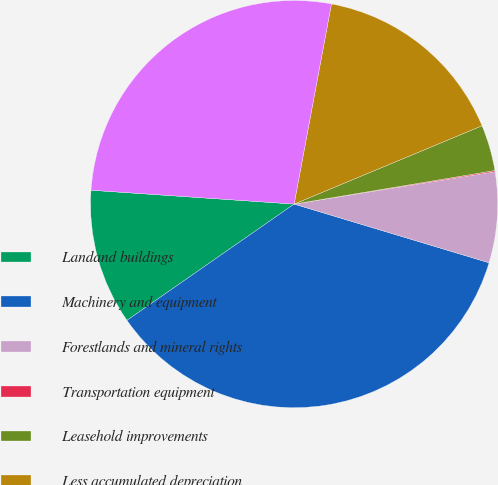Convert chart to OTSL. <chart><loc_0><loc_0><loc_500><loc_500><pie_chart><fcel>Landand buildings<fcel>Machinery and equipment<fcel>Forestlands and mineral rights<fcel>Transportation equipment<fcel>Leasehold improvements<fcel>Less accumulated depreciation<fcel>Property plant and equipment<nl><fcel>10.76%<fcel>35.67%<fcel>7.2%<fcel>0.09%<fcel>3.65%<fcel>15.78%<fcel>26.85%<nl></chart> 